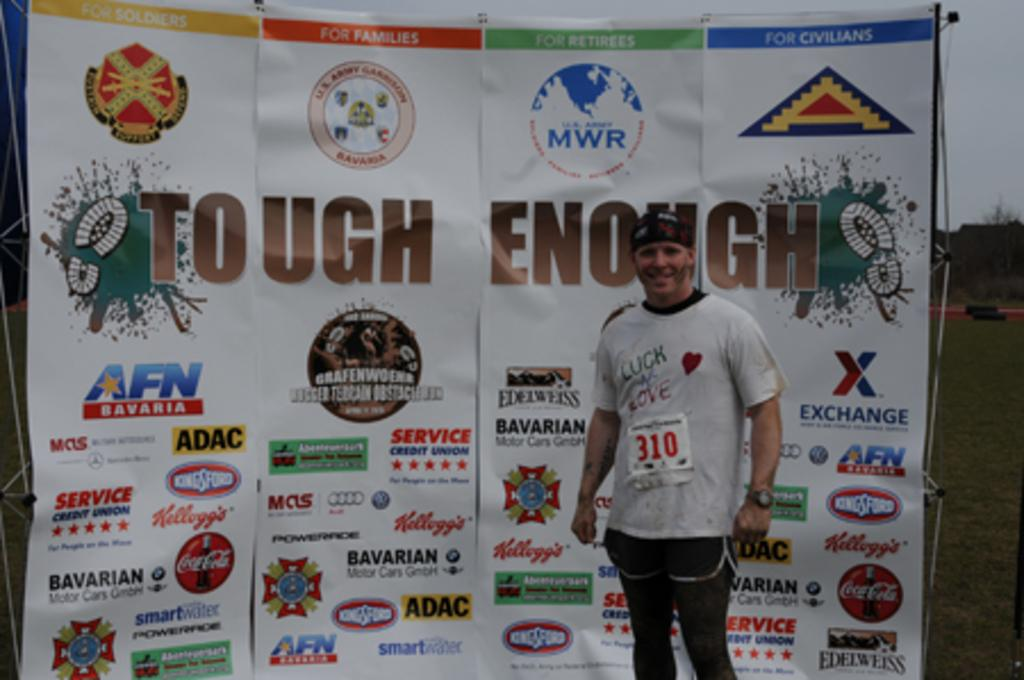Provide a one-sentence caption for the provided image. A man stands in front of a Tough Enough sign. 